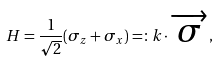<formula> <loc_0><loc_0><loc_500><loc_500>H = \frac { 1 } { \sqrt { 2 } } ( \sigma _ { z } + \sigma _ { x } ) = \colon { k } \cdot \overrightarrow { \sigma } ,</formula> 